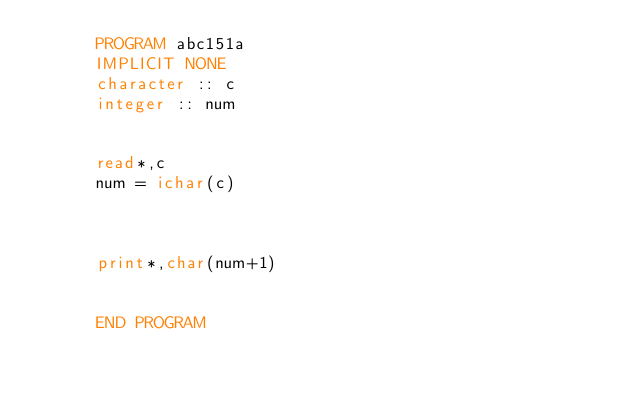<code> <loc_0><loc_0><loc_500><loc_500><_FORTRAN_>      PROGRAM abc151a
      IMPLICIT NONE
      character :: c
      integer :: num
      
      
      read*,c
      num = ichar(c)
      
      
      
      print*,char(num+1)
      
      
      END PROGRAM</code> 